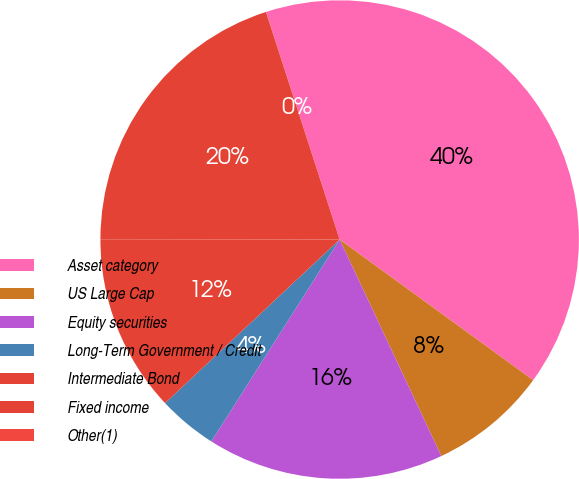Convert chart. <chart><loc_0><loc_0><loc_500><loc_500><pie_chart><fcel>Asset category<fcel>US Large Cap<fcel>Equity securities<fcel>Long-Term Government / Credit<fcel>Intermediate Bond<fcel>Fixed income<fcel>Other(1)<nl><fcel>39.98%<fcel>8.01%<fcel>16.0%<fcel>4.01%<fcel>12.0%<fcel>20.0%<fcel>0.01%<nl></chart> 